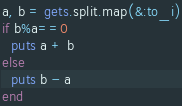Convert code to text. <code><loc_0><loc_0><loc_500><loc_500><_Ruby_>a, b = gets.split.map(&:to_i)
if b%a==0
  puts a + b
else
  puts b - a
end</code> 